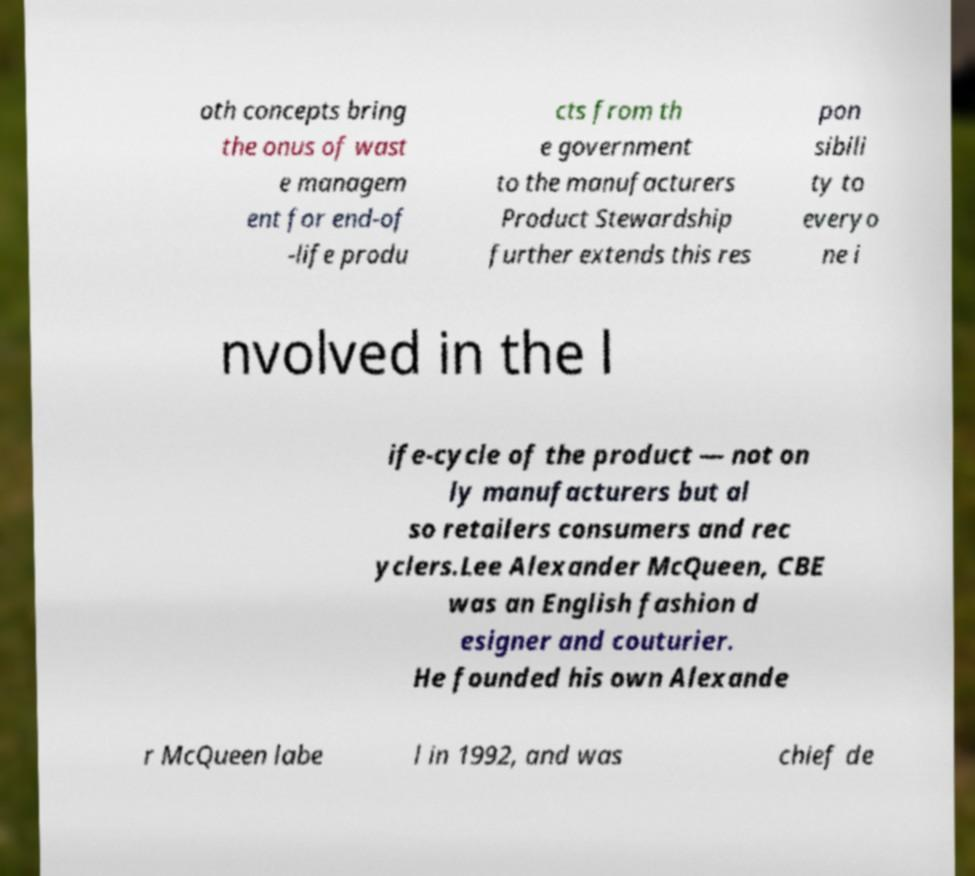There's text embedded in this image that I need extracted. Can you transcribe it verbatim? oth concepts bring the onus of wast e managem ent for end-of -life produ cts from th e government to the manufacturers Product Stewardship further extends this res pon sibili ty to everyo ne i nvolved in the l ife-cycle of the product — not on ly manufacturers but al so retailers consumers and rec yclers.Lee Alexander McQueen, CBE was an English fashion d esigner and couturier. He founded his own Alexande r McQueen labe l in 1992, and was chief de 